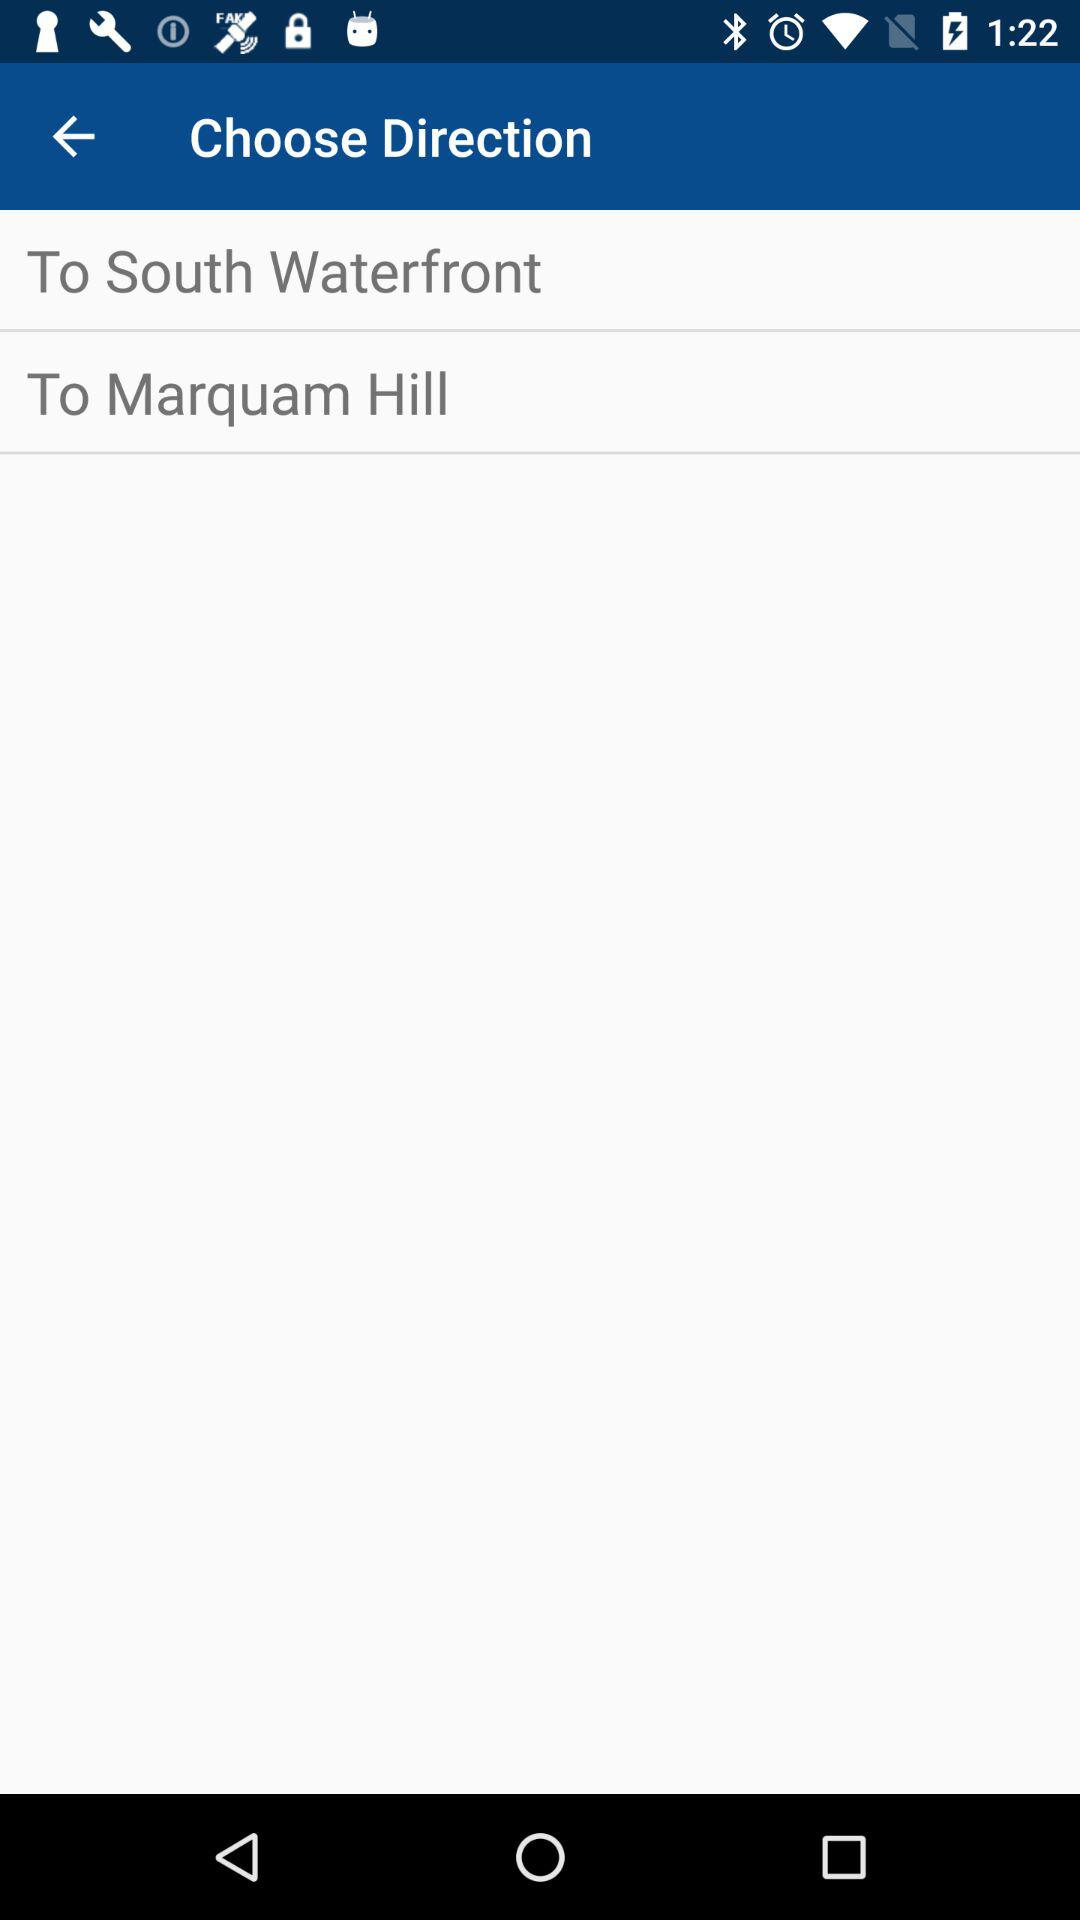What are the options for direction? The options for direction are "To South Waterfront" and "To Marquam Hill". 